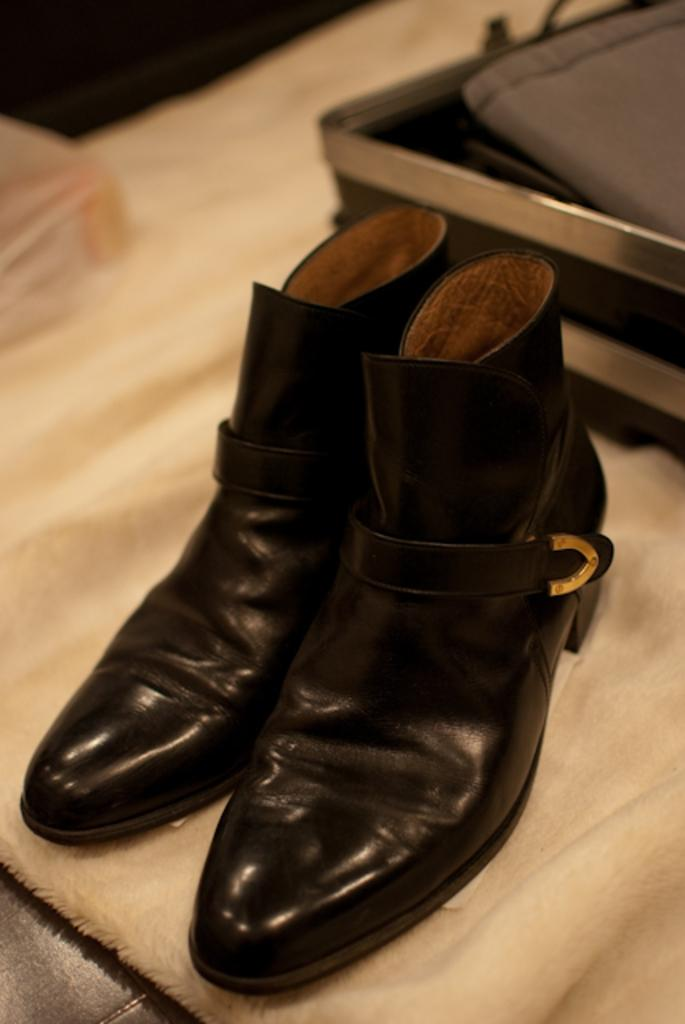What is the color of the mat in the image? There is a cream-colored mat in the image. What is placed on the mat? There is a pair of black shoes on the mat. What can be found behind the shoes? There is a box behind the shoes. What is inside the box? The box contains a gray-colored cloth. Can you see a friend sitting next to the stream in the image? There is no friend or stream present in the image. What type of sweater is the person wearing in the image? There is no person or sweater present in the image. 